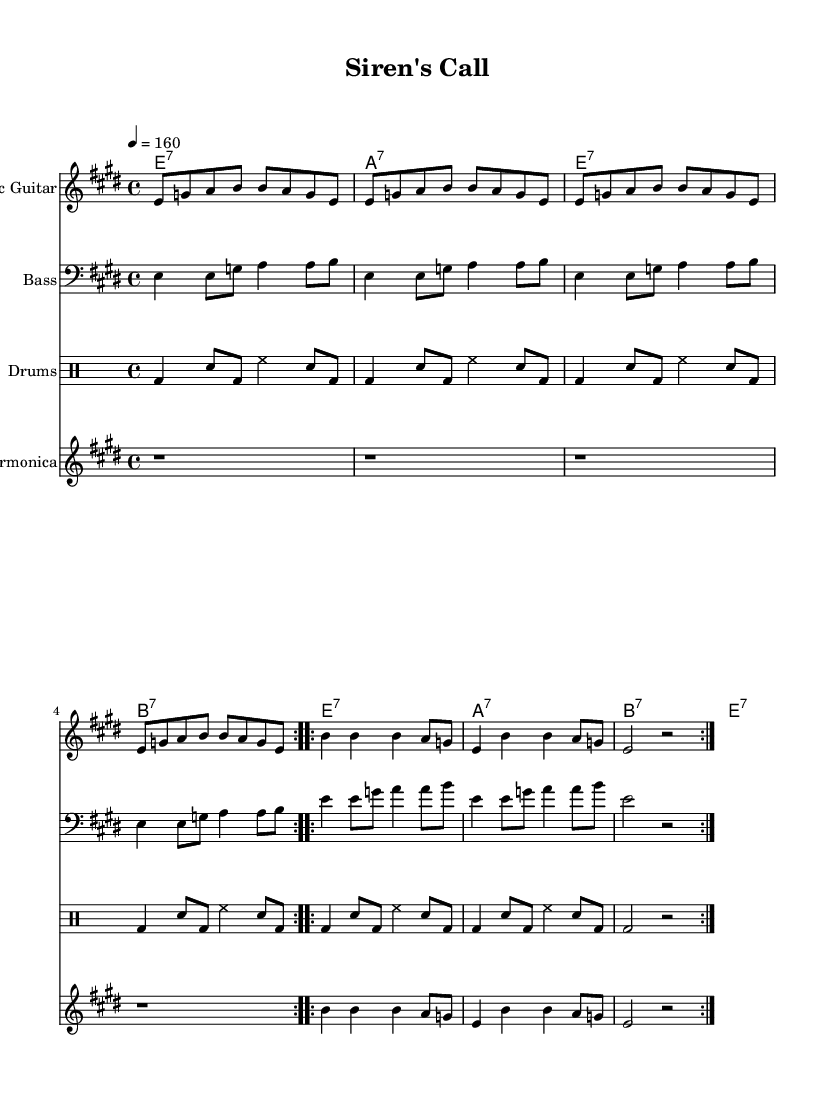What is the key signature of this music? The key signature is E major, which has four sharps: F sharp, C sharp, G sharp, and D sharp.
Answer: E major What is the time signature of the piece? The time signature is indicated as 4/4, which means there are four beats in each measure and a quarter note receives one beat.
Answer: 4/4 What is the tempo marking for this music? The tempo marking is given as a quarter note equals 160 beats per minute, indicating a fast-paced rhythm suitable for the genre.
Answer: 160 How many times is the main guitar theme repeated according to the section? The main guitar theme is repeated four times, as indicated by the repeat signs and volta markings in the notation.
Answer: Four times What chords are used in the progression during the chorus? The chords used in the progression during the chorus are E7, A7, and B7, which are characteristic of the electric blues genre.
Answer: E7, A7, B7 What is the function of the harmonica in this piece? The harmonica serves as a melodic embellishment in the piece, providing a bluesy sound that complements the electric guitar part.
Answer: Melodic embellishment What type of rhythm section is employed for the drums? The rhythm section for the drums uses a backbeat pattern, emphasizing the snare drum on the second and fourth beats to create a driving groove.
Answer: Backbeat pattern 